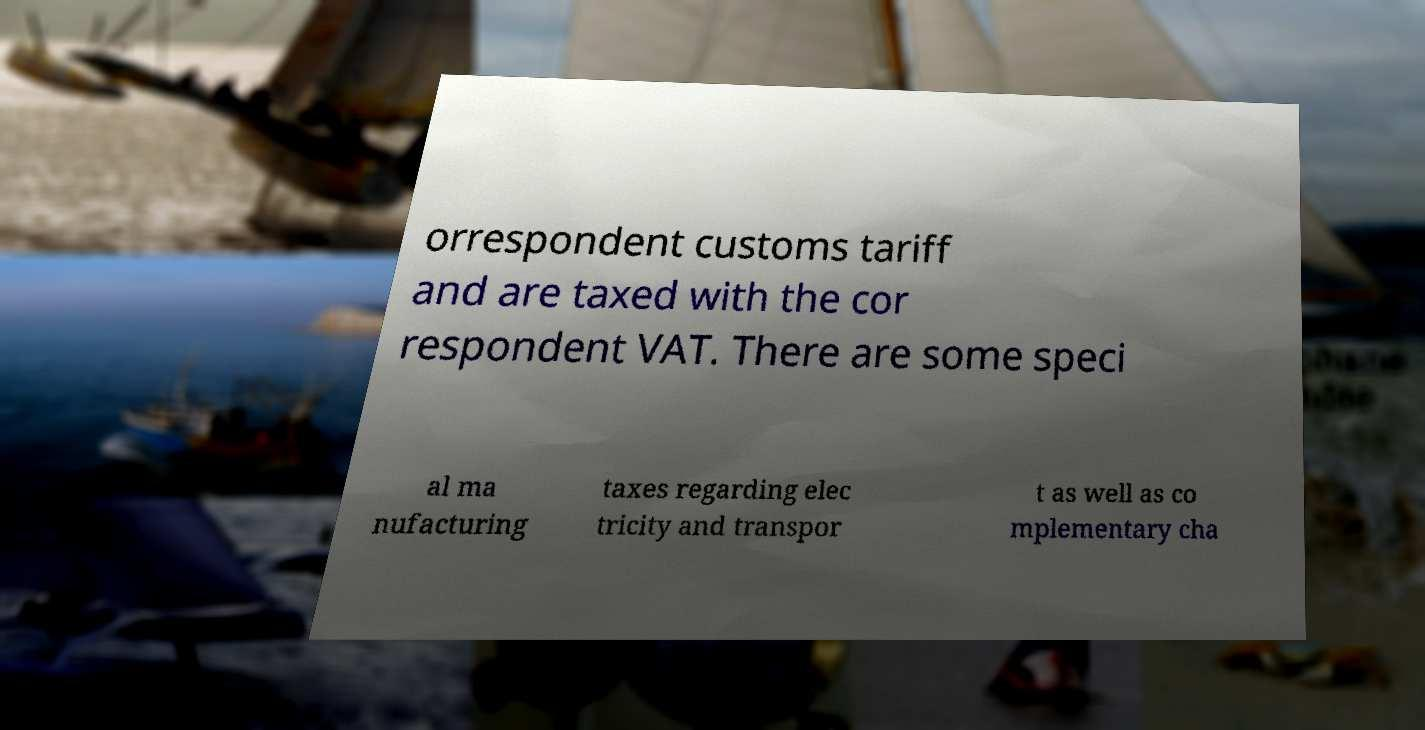For documentation purposes, I need the text within this image transcribed. Could you provide that? orrespondent customs tariff and are taxed with the cor respondent VAT. There are some speci al ma nufacturing taxes regarding elec tricity and transpor t as well as co mplementary cha 